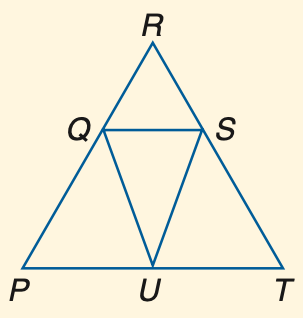Answer the mathemtical geometry problem and directly provide the correct option letter.
Question: If R Q \cong R S and m \angle R Q S = 75, find m \angle R.
Choices: A: 30 B: 40 C: 52.5 D: 75 A 